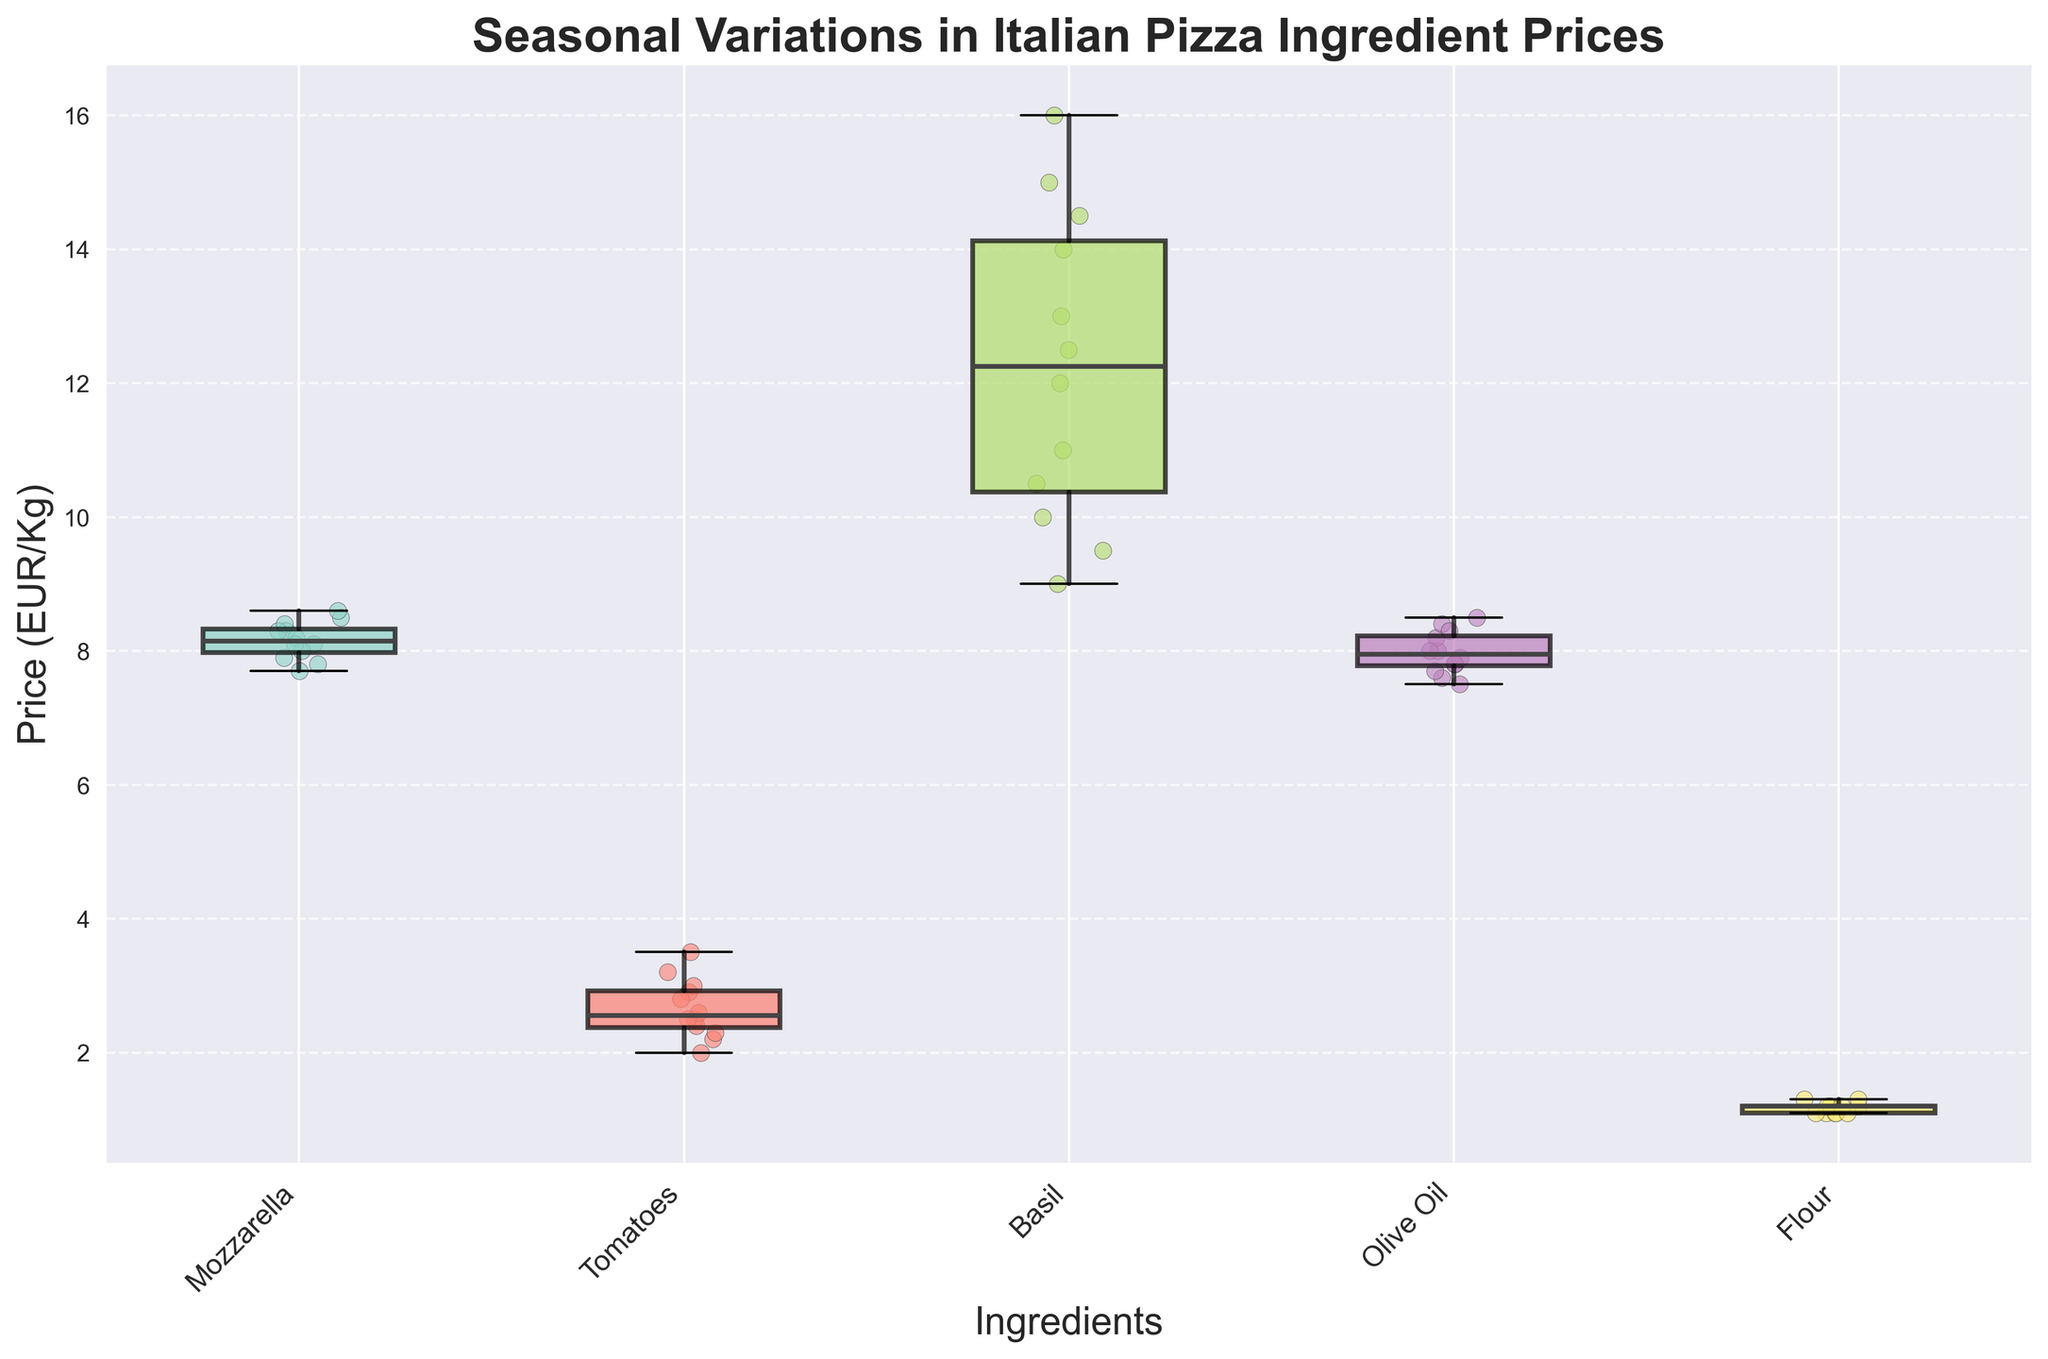What's the title of the plot? The title of the plot is displayed on the plot, typically at the top. It reads "Seasonal Variations in Italian Pizza Ingredient Prices", which indicates the main focus of the figure.
Answer: Seasonal Variations in Italian Pizza Ingredient Prices What do the x-axis labels represent? The x-axis labels represent the various ingredients used in Italian pizza such as Mozzarella, Tomatoes, Basil, Olive Oil, and Flour. These are categorized to show their respective price variations over different months.
Answer: Different pizza ingredients What is the median price of Tomatoes? To find the median price of Tomatoes, look at the black line inside the Tomato box in the box plot. The median line for Tomatoes is slightly above the 2.5 EUR/Kg mark, making it the central value of the Tomato prices across the year.
Answer: Slightly above 2.5 EUR/Kg Which ingredient shows the greatest price fluctuation? Price fluctuation in a box plot is represented by the spread and whiskers. By visually comparing, Basil shows the largest spread between the lower and upper whiskers, indicating the greatest price fluctuation.
Answer: Basil How do summer months (June to August) impact the price of Tomatoes compared to winter months (January to March)? Review the scatter points for Tomatoes during summer (June to August) and winter (January to March). Summer months show higher prices (around 3.0 to 3.5 EUR/Kg) compared to winter months (around 2.0 to 2.4 EUR/Kg).
Answer: Higher in summer Which ingredient does not show much seasonal variation throughout the year? By examining the variability (spread) of the boxes and whiskers, the ingredient with the least variation would be Flour, as it has a relatively narrow box and short whiskers indicating little change.
Answer: Flour What is the general trend in the price of Mozzarella from January to December? By observing the scatter points along the Mozzarella box and their movement from January to December, the prices slightly decrease from January (8.5 EUR/Kg) to a low in August (7.7 EUR/Kg), and then increase again towards December (8.6 EUR/Kg).
Answer: Decrease then increase Which ingredient consistently shows the highest median price throughout the year? Looking at the median lines in each box plot, Basil's median price line is consistently higher than other ingredients, making it the highest priced ingredient on the list.
Answer: Basil 